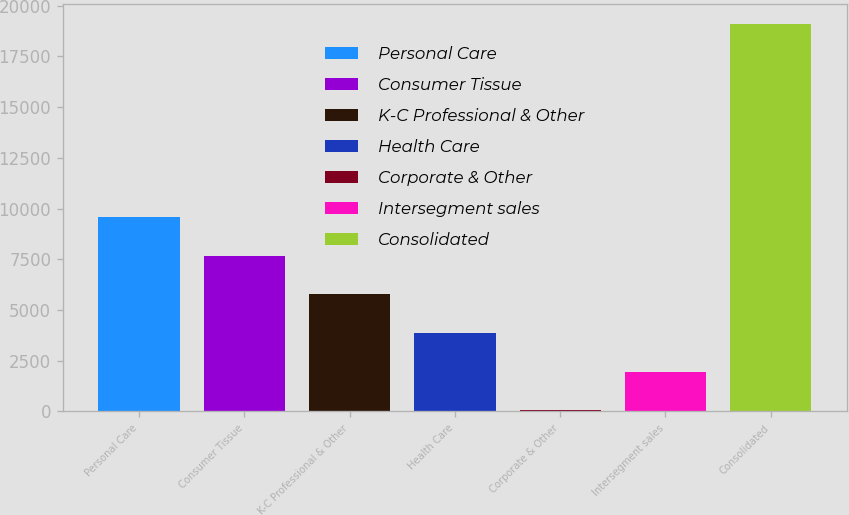<chart> <loc_0><loc_0><loc_500><loc_500><bar_chart><fcel>Personal Care<fcel>Consumer Tissue<fcel>K-C Professional & Other<fcel>Health Care<fcel>Corporate & Other<fcel>Intersegment sales<fcel>Consolidated<nl><fcel>9584<fcel>7677.8<fcel>5771.6<fcel>3865.4<fcel>53<fcel>1959.2<fcel>19115<nl></chart> 